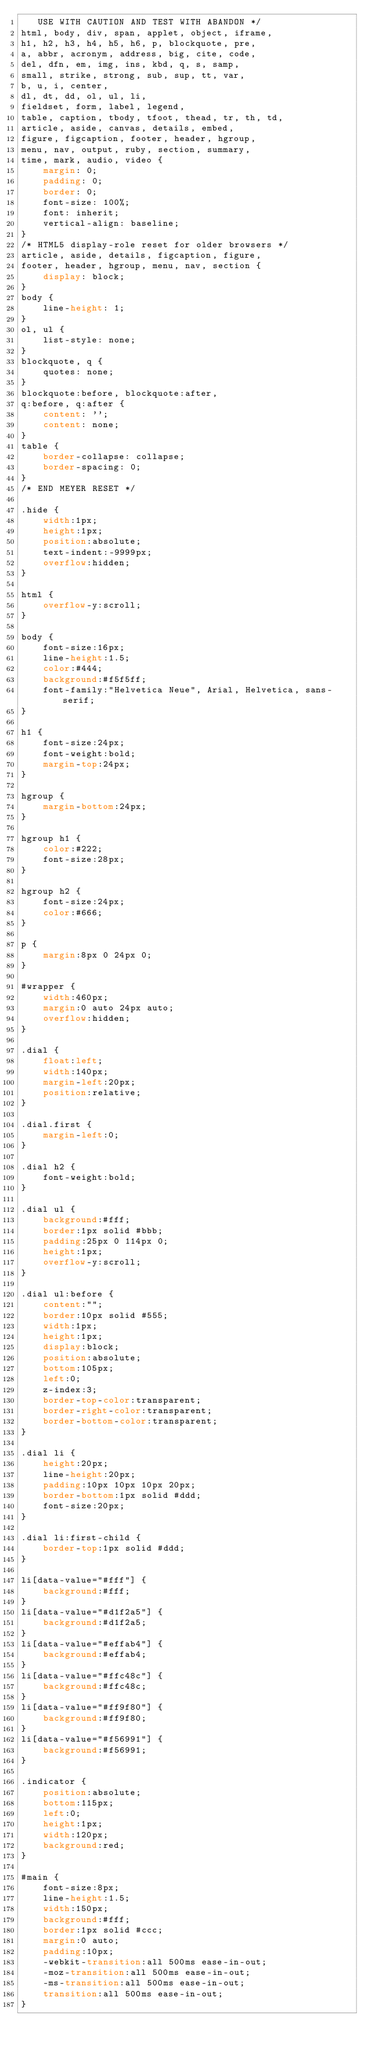Convert code to text. <code><loc_0><loc_0><loc_500><loc_500><_CSS_>   USE WITH CAUTION AND TEST WITH ABANDON */
html, body, div, span, applet, object, iframe,
h1, h2, h3, h4, h5, h6, p, blockquote, pre,
a, abbr, acronym, address, big, cite, code,
del, dfn, em, img, ins, kbd, q, s, samp,
small, strike, strong, sub, sup, tt, var,
b, u, i, center,
dl, dt, dd, ol, ul, li,
fieldset, form, label, legend,
table, caption, tbody, tfoot, thead, tr, th, td,
article, aside, canvas, details, embed, 
figure, figcaption, footer, header, hgroup, 
menu, nav, output, ruby, section, summary,
time, mark, audio, video {
	margin: 0;
	padding: 0;
	border: 0;
	font-size: 100%;
	font: inherit;
	vertical-align: baseline;
}
/* HTML5 display-role reset for older browsers */
article, aside, details, figcaption, figure, 
footer, header, hgroup, menu, nav, section {
	display: block;
}
body {
	line-height: 1;
}
ol, ul {
	list-style: none;
}
blockquote, q {
	quotes: none;
}
blockquote:before, blockquote:after,
q:before, q:after {
	content: '';
	content: none;
}
table {
	border-collapse: collapse;
	border-spacing: 0;
}
/* END MEYER RESET */

.hide {
	width:1px;
	height:1px;
	position:absolute;
	text-indent:-9999px;
	overflow:hidden;
}

html {
	overflow-y:scroll;
}

body {
	font-size:16px;
	line-height:1.5;
	color:#444;
	background:#f5f5ff;
	font-family:"Helvetica Neue", Arial, Helvetica, sans-serif;
}

h1 {
	font-size:24px;
	font-weight:bold;
	margin-top:24px;
}

hgroup {
	margin-bottom:24px;
}

hgroup h1 {
	color:#222;
	font-size:28px;
}

hgroup h2 {
	font-size:24px;
	color:#666;
}

p {
	margin:8px 0 24px 0;
}

#wrapper {
	width:460px;
	margin:0 auto 24px auto;
	overflow:hidden;
}

.dial {
	float:left;
	width:140px;
	margin-left:20px;
	position:relative;
}

.dial.first {
	margin-left:0;
}

.dial h2 {
	font-weight:bold;
}

.dial ul {
	background:#fff;
	border:1px solid #bbb;
	padding:25px 0 114px 0;
	height:1px;
	overflow-y:scroll;
}

.dial ul:before {
	content:"";
	border:10px solid #555;
	width:1px;
	height:1px;
	display:block;
	position:absolute;
	bottom:105px;
	left:0;
	z-index:3;
	border-top-color:transparent;
	border-right-color:transparent;
	border-bottom-color:transparent;
}

.dial li {
	height:20px;
	line-height:20px;
	padding:10px 10px 10px 20px;
	border-bottom:1px solid #ddd;
	font-size:20px;
}

.dial li:first-child {
	border-top:1px solid #ddd;
}

li[data-value="#fff"] {
	background:#fff;
}
li[data-value="#d1f2a5"] {
	background:#d1f2a5;
}
li[data-value="#effab4"] {
	background:#effab4;
}
li[data-value="#ffc48c"] {
	background:#ffc48c;
}
li[data-value="#ff9f80"] {
	background:#ff9f80;
}
li[data-value="#f56991"] {
	background:#f56991;
}

.indicator {
	position:absolute;
	bottom:115px;
	left:0;
	height:1px;
	width:120px;
	background:red;
}

#main {
	font-size:8px;
	line-height:1.5;
	width:150px;
	background:#fff;
	border:1px solid #ccc;
	margin:0 auto;
	padding:10px;
	-webkit-transition:all 500ms ease-in-out;
	-moz-transition:all 500ms ease-in-out;
	-ms-transition:all 500ms ease-in-out;
	transition:all 500ms ease-in-out;
}

</code> 